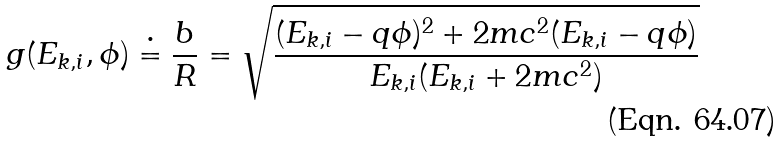<formula> <loc_0><loc_0><loc_500><loc_500>g ( E _ { k , i } , \phi ) \doteq \frac { b } { R } = \sqrt { \frac { ( E _ { k , i } - q \phi ) ^ { 2 } + 2 m c ^ { 2 } ( E _ { k , i } - q \phi ) } { E _ { k , i } ( E _ { k , i } + 2 m c ^ { 2 } ) } }</formula> 